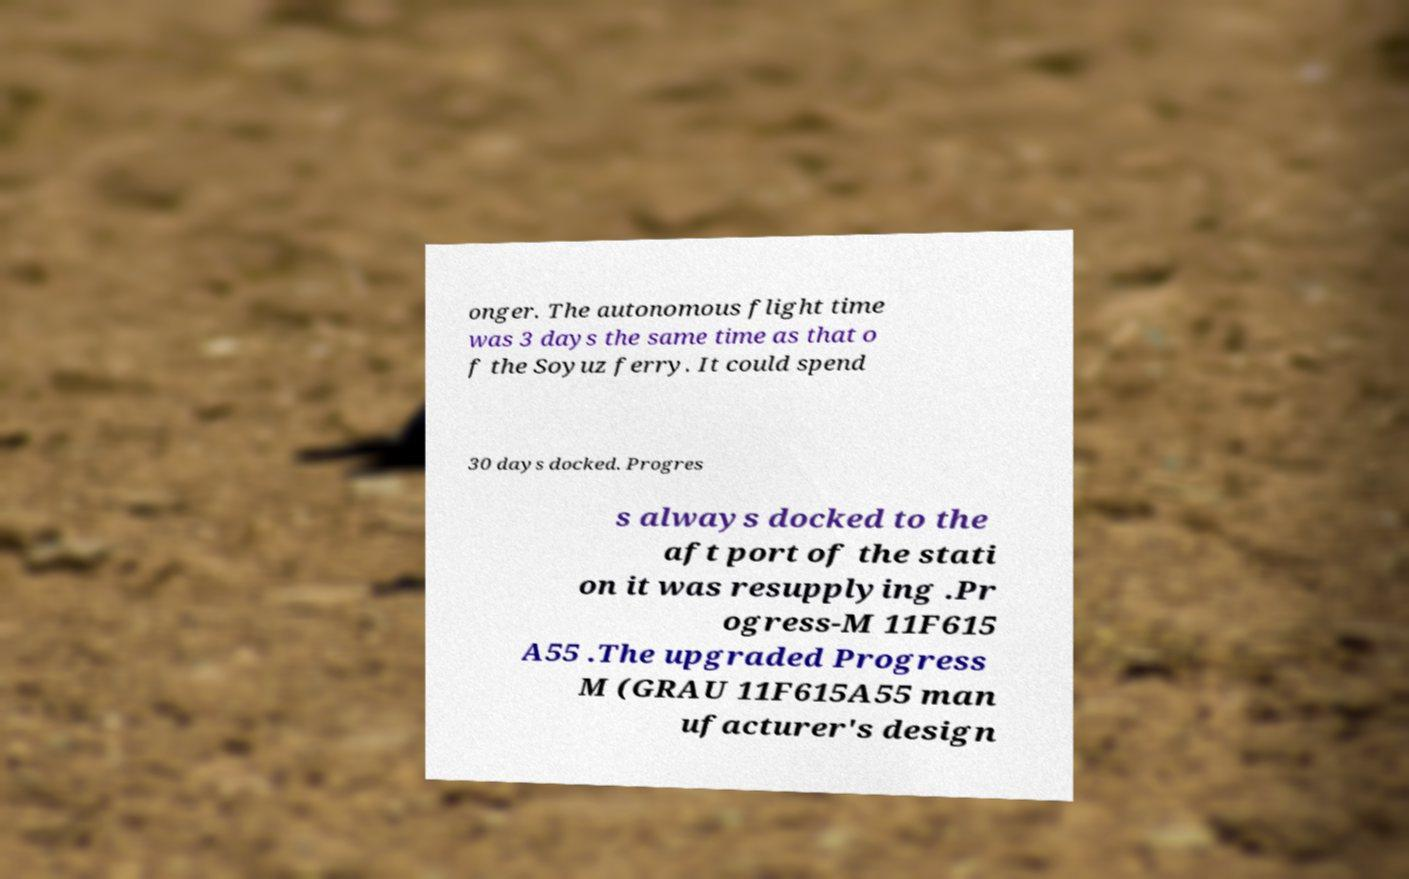There's text embedded in this image that I need extracted. Can you transcribe it verbatim? onger. The autonomous flight time was 3 days the same time as that o f the Soyuz ferry. It could spend 30 days docked. Progres s always docked to the aft port of the stati on it was resupplying .Pr ogress-M 11F615 A55 .The upgraded Progress M (GRAU 11F615A55 man ufacturer's design 